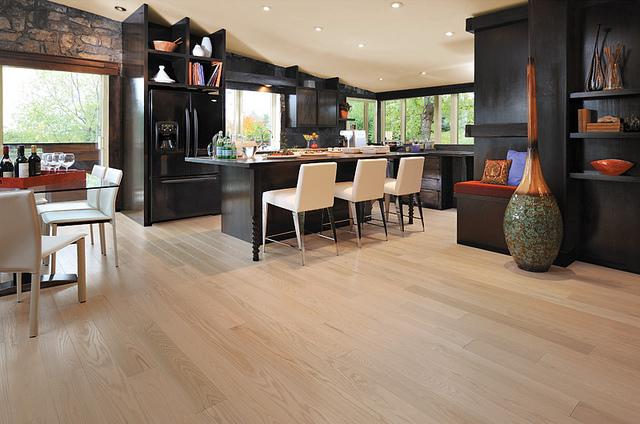How tall is the vase?
Answer briefly. 6 feet. What room is this?
Concise answer only. Kitchen. What color are the chairs?
Be succinct. White. 